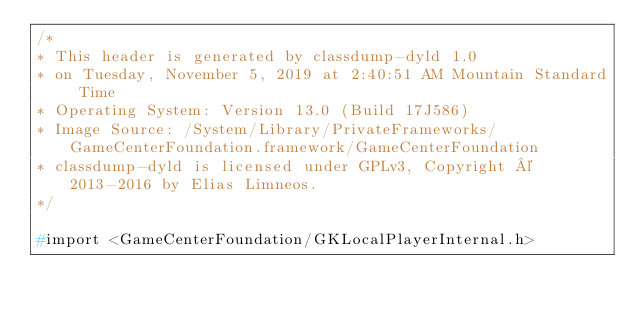<code> <loc_0><loc_0><loc_500><loc_500><_C_>/*
* This header is generated by classdump-dyld 1.0
* on Tuesday, November 5, 2019 at 2:40:51 AM Mountain Standard Time
* Operating System: Version 13.0 (Build 17J586)
* Image Source: /System/Library/PrivateFrameworks/GameCenterFoundation.framework/GameCenterFoundation
* classdump-dyld is licensed under GPLv3, Copyright © 2013-2016 by Elias Limneos.
*/

#import <GameCenterFoundation/GKLocalPlayerInternal.h>
</code> 